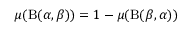<formula> <loc_0><loc_0><loc_500><loc_500>\mu ( B ( \alpha , \beta ) ) = 1 - \mu ( B ( \beta , \alpha ) )</formula> 